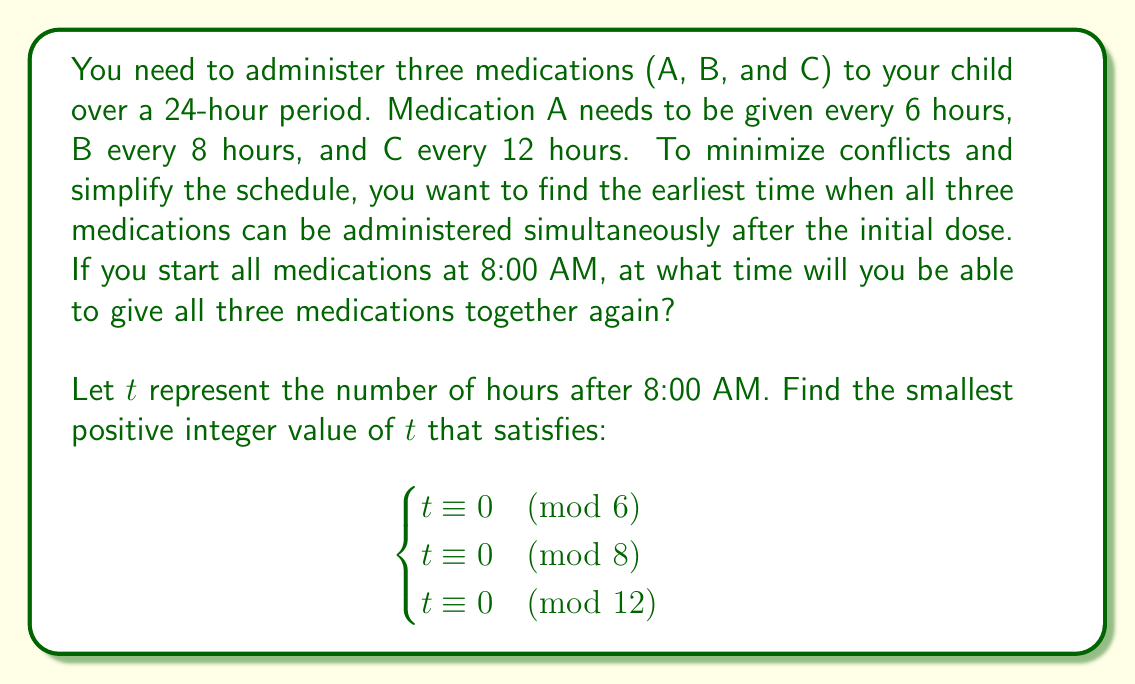Could you help me with this problem? To solve this problem, we need to find the least common multiple (LCM) of 6, 8, and 12. This will give us the number of hours after which all three medication schedules align.

Step 1: Find the prime factorization of each number.
6 = $2 \times 3$
8 = $2^3$
12 = $2^2 \times 3$

Step 2: Take the highest power of each prime factor.
$LCM(6, 8, 12) = 2^3 \times 3 = 8 \times 3 = 24$

Step 3: Verify that 24 satisfies all three conditions:
24 ÷ 6 = 4 (remainder 0)
24 ÷ 8 = 3 (remainder 0)
24 ÷ 12 = 2 (remainder 0)

Step 4: Calculate the time 24 hours after 8:00 AM.
8:00 AM + 24 hours = 8:00 AM the next day

Therefore, all three medications can be administered together again at 8:00 AM the following day, 24 hours after the initial dose.
Answer: 8:00 AM the next day 